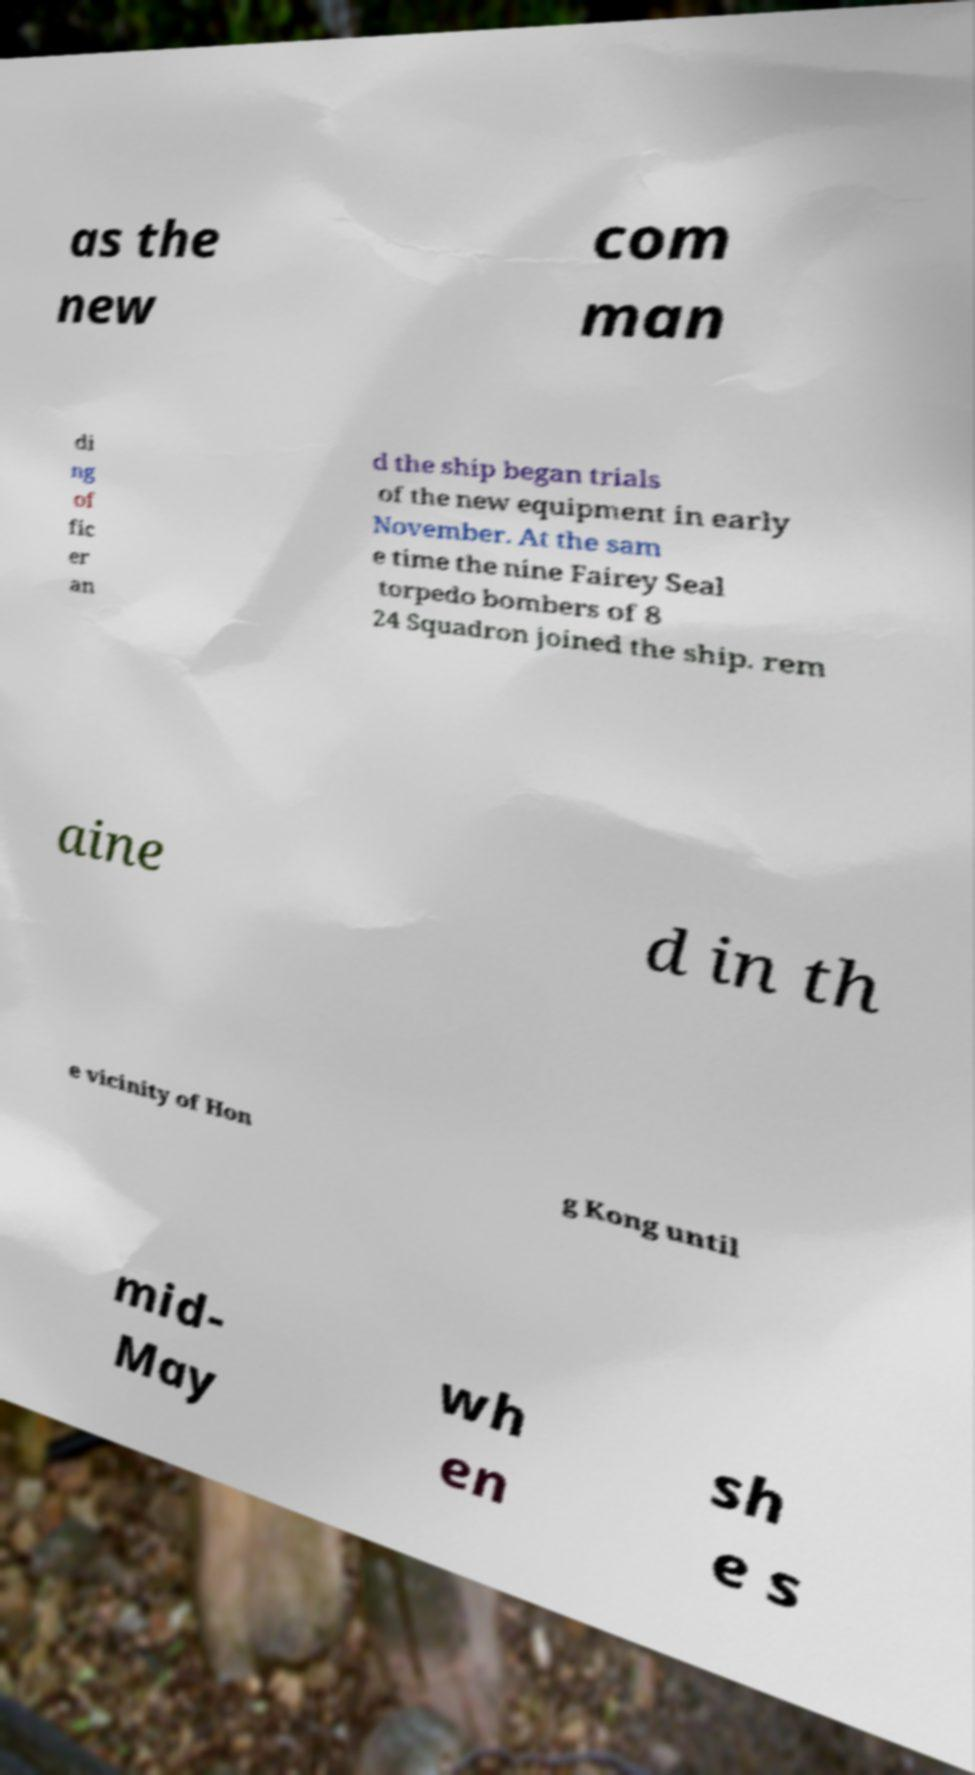For documentation purposes, I need the text within this image transcribed. Could you provide that? as the new com man di ng of fic er an d the ship began trials of the new equipment in early November. At the sam e time the nine Fairey Seal torpedo bombers of 8 24 Squadron joined the ship. rem aine d in th e vicinity of Hon g Kong until mid- May wh en sh e s 